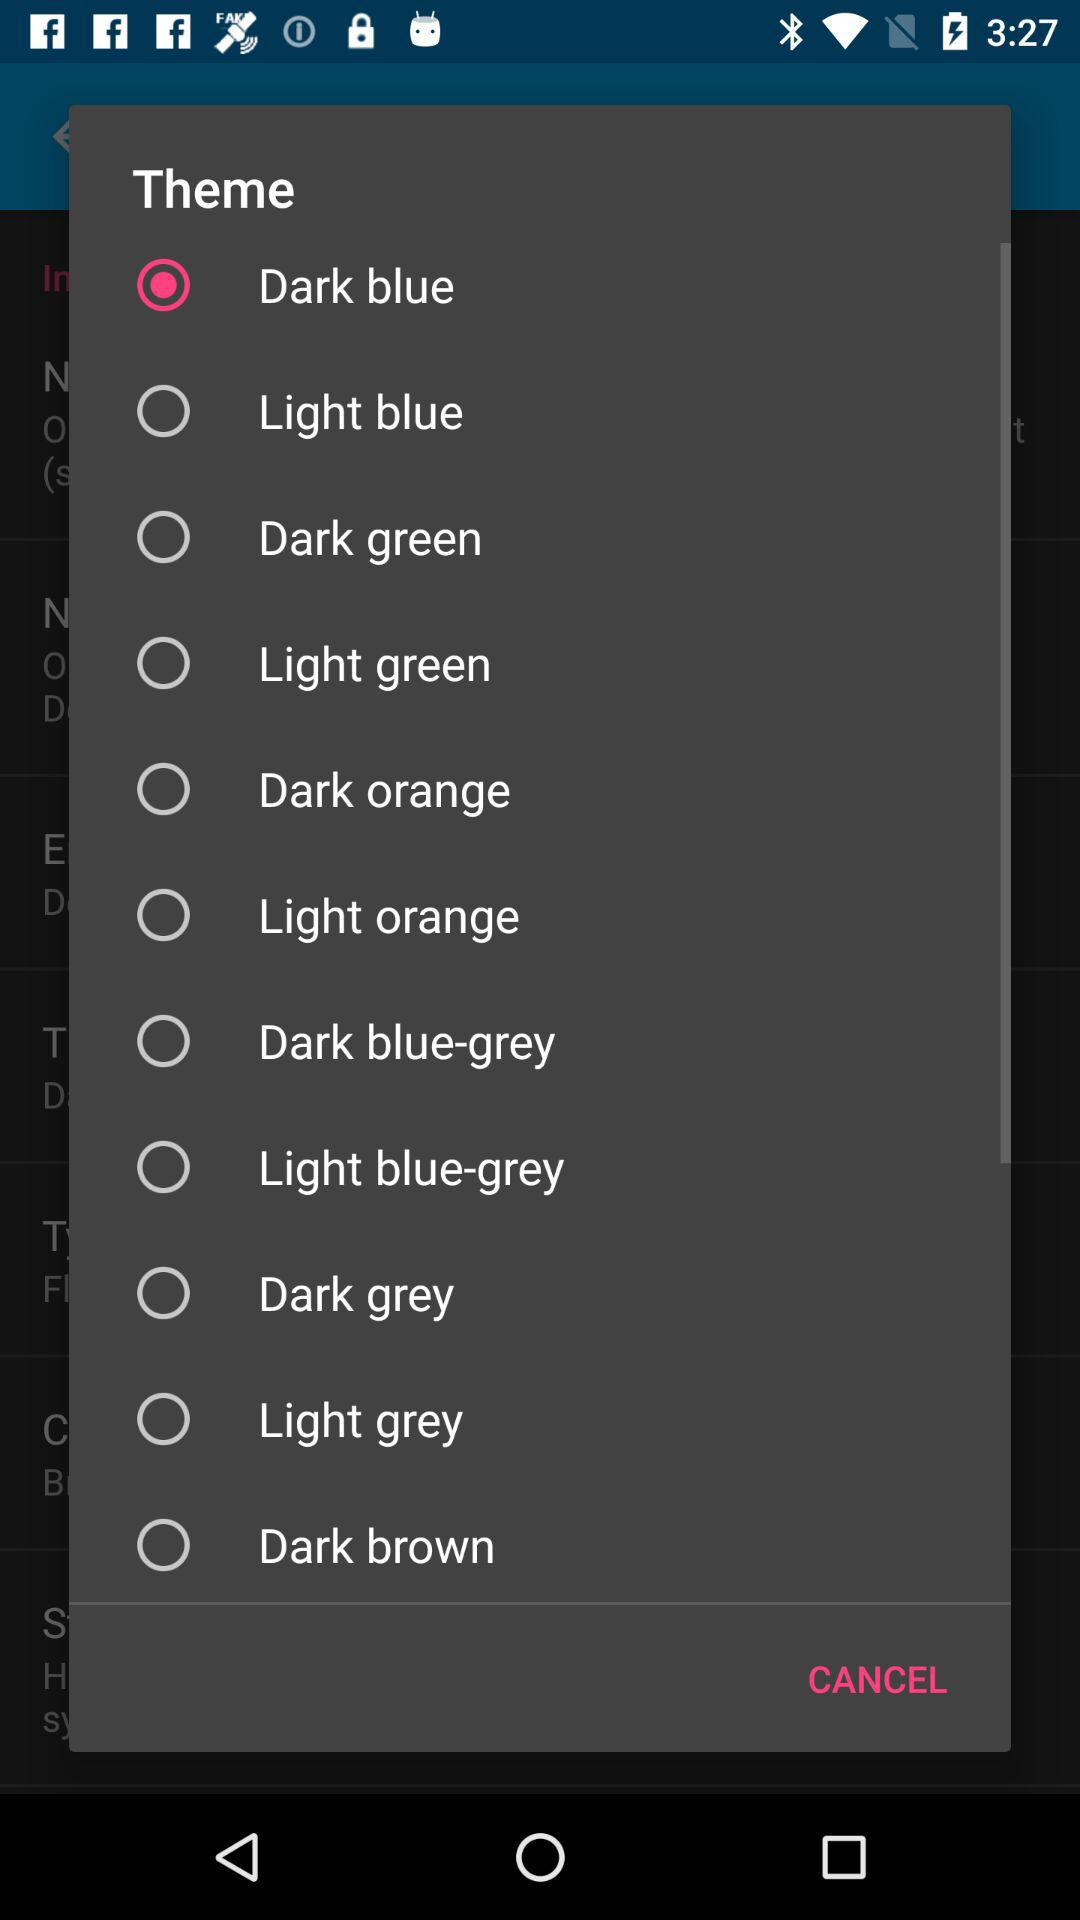How many more light blue themes are there than dark blue themes?
Answer the question using a single word or phrase. 1 